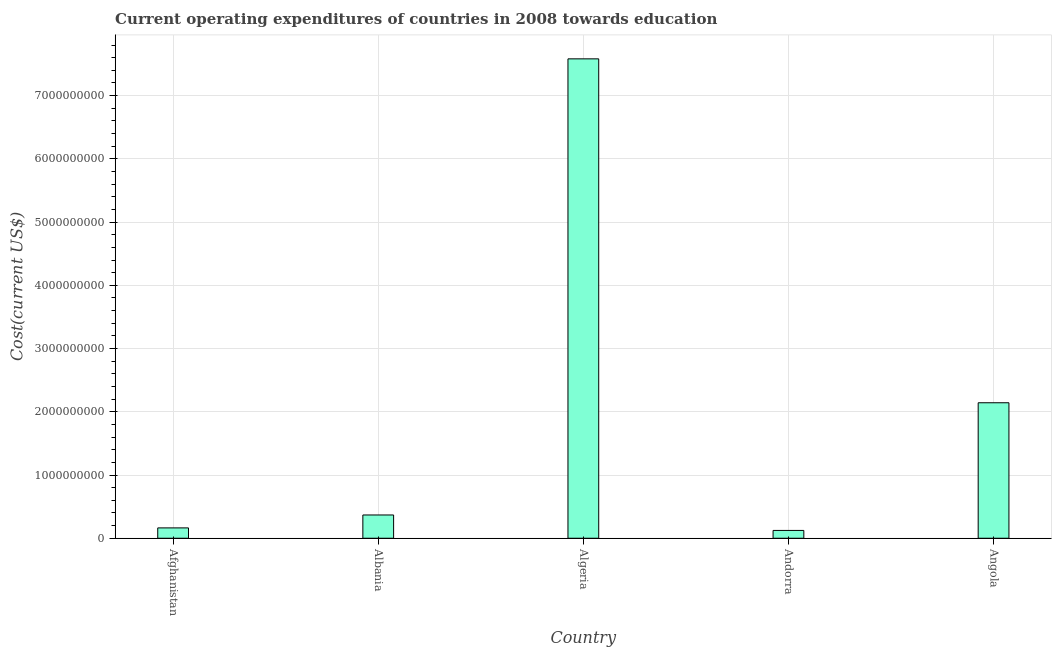Does the graph contain any zero values?
Give a very brief answer. No. Does the graph contain grids?
Make the answer very short. Yes. What is the title of the graph?
Your response must be concise. Current operating expenditures of countries in 2008 towards education. What is the label or title of the X-axis?
Offer a terse response. Country. What is the label or title of the Y-axis?
Keep it short and to the point. Cost(current US$). What is the education expenditure in Afghanistan?
Make the answer very short. 1.64e+08. Across all countries, what is the maximum education expenditure?
Your answer should be very brief. 7.58e+09. Across all countries, what is the minimum education expenditure?
Offer a terse response. 1.24e+08. In which country was the education expenditure maximum?
Offer a terse response. Algeria. In which country was the education expenditure minimum?
Provide a short and direct response. Andorra. What is the sum of the education expenditure?
Your answer should be very brief. 1.04e+1. What is the difference between the education expenditure in Algeria and Angola?
Offer a very short reply. 5.44e+09. What is the average education expenditure per country?
Offer a very short reply. 2.08e+09. What is the median education expenditure?
Give a very brief answer. 3.68e+08. What is the ratio of the education expenditure in Algeria to that in Angola?
Give a very brief answer. 3.54. Is the education expenditure in Afghanistan less than that in Algeria?
Give a very brief answer. Yes. What is the difference between the highest and the second highest education expenditure?
Your response must be concise. 5.44e+09. Is the sum of the education expenditure in Afghanistan and Angola greater than the maximum education expenditure across all countries?
Your answer should be very brief. No. What is the difference between the highest and the lowest education expenditure?
Make the answer very short. 7.46e+09. How many bars are there?
Offer a very short reply. 5. Are all the bars in the graph horizontal?
Give a very brief answer. No. How many countries are there in the graph?
Your response must be concise. 5. What is the difference between two consecutive major ticks on the Y-axis?
Your answer should be compact. 1.00e+09. What is the Cost(current US$) in Afghanistan?
Your answer should be compact. 1.64e+08. What is the Cost(current US$) of Albania?
Provide a succinct answer. 3.68e+08. What is the Cost(current US$) of Algeria?
Offer a very short reply. 7.58e+09. What is the Cost(current US$) of Andorra?
Make the answer very short. 1.24e+08. What is the Cost(current US$) in Angola?
Make the answer very short. 2.14e+09. What is the difference between the Cost(current US$) in Afghanistan and Albania?
Your answer should be very brief. -2.04e+08. What is the difference between the Cost(current US$) in Afghanistan and Algeria?
Your response must be concise. -7.42e+09. What is the difference between the Cost(current US$) in Afghanistan and Andorra?
Your answer should be very brief. 4.02e+07. What is the difference between the Cost(current US$) in Afghanistan and Angola?
Make the answer very short. -1.98e+09. What is the difference between the Cost(current US$) in Albania and Algeria?
Your response must be concise. -7.21e+09. What is the difference between the Cost(current US$) in Albania and Andorra?
Offer a terse response. 2.44e+08. What is the difference between the Cost(current US$) in Albania and Angola?
Your answer should be compact. -1.77e+09. What is the difference between the Cost(current US$) in Algeria and Andorra?
Give a very brief answer. 7.46e+09. What is the difference between the Cost(current US$) in Algeria and Angola?
Keep it short and to the point. 5.44e+09. What is the difference between the Cost(current US$) in Andorra and Angola?
Keep it short and to the point. -2.02e+09. What is the ratio of the Cost(current US$) in Afghanistan to that in Albania?
Your answer should be compact. 0.45. What is the ratio of the Cost(current US$) in Afghanistan to that in Algeria?
Offer a terse response. 0.02. What is the ratio of the Cost(current US$) in Afghanistan to that in Andorra?
Provide a succinct answer. 1.32. What is the ratio of the Cost(current US$) in Afghanistan to that in Angola?
Provide a succinct answer. 0.08. What is the ratio of the Cost(current US$) in Albania to that in Algeria?
Your response must be concise. 0.05. What is the ratio of the Cost(current US$) in Albania to that in Andorra?
Make the answer very short. 2.98. What is the ratio of the Cost(current US$) in Albania to that in Angola?
Ensure brevity in your answer.  0.17. What is the ratio of the Cost(current US$) in Algeria to that in Andorra?
Make the answer very short. 61.36. What is the ratio of the Cost(current US$) in Algeria to that in Angola?
Your response must be concise. 3.54. What is the ratio of the Cost(current US$) in Andorra to that in Angola?
Your answer should be very brief. 0.06. 